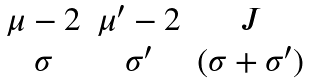<formula> <loc_0><loc_0><loc_500><loc_500>\begin{matrix} \mu - 2 & \mu ^ { \prime } - 2 & J \\ \sigma & \sigma ^ { \prime } & ( \sigma + \sigma ^ { \prime } ) \end{matrix}</formula> 